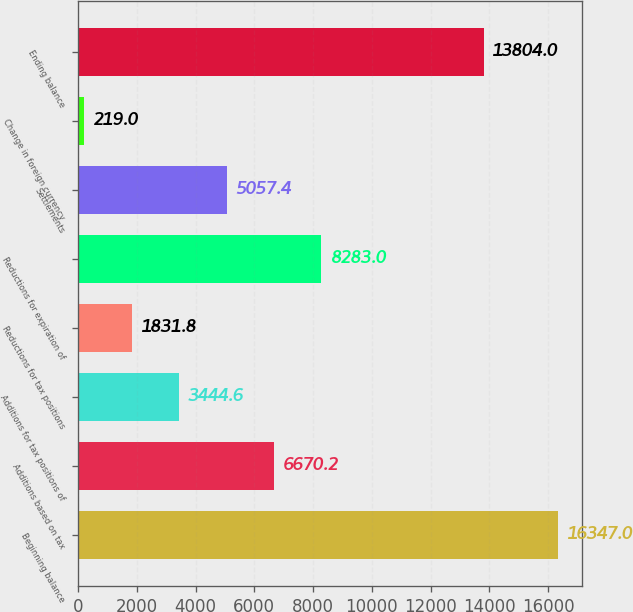<chart> <loc_0><loc_0><loc_500><loc_500><bar_chart><fcel>Beginning balance<fcel>Additions based on tax<fcel>Additions for tax positions of<fcel>Reductions for tax positions<fcel>Reductions for expiration of<fcel>Settlements<fcel>Change in foreign currency<fcel>Ending balance<nl><fcel>16347<fcel>6670.2<fcel>3444.6<fcel>1831.8<fcel>8283<fcel>5057.4<fcel>219<fcel>13804<nl></chart> 